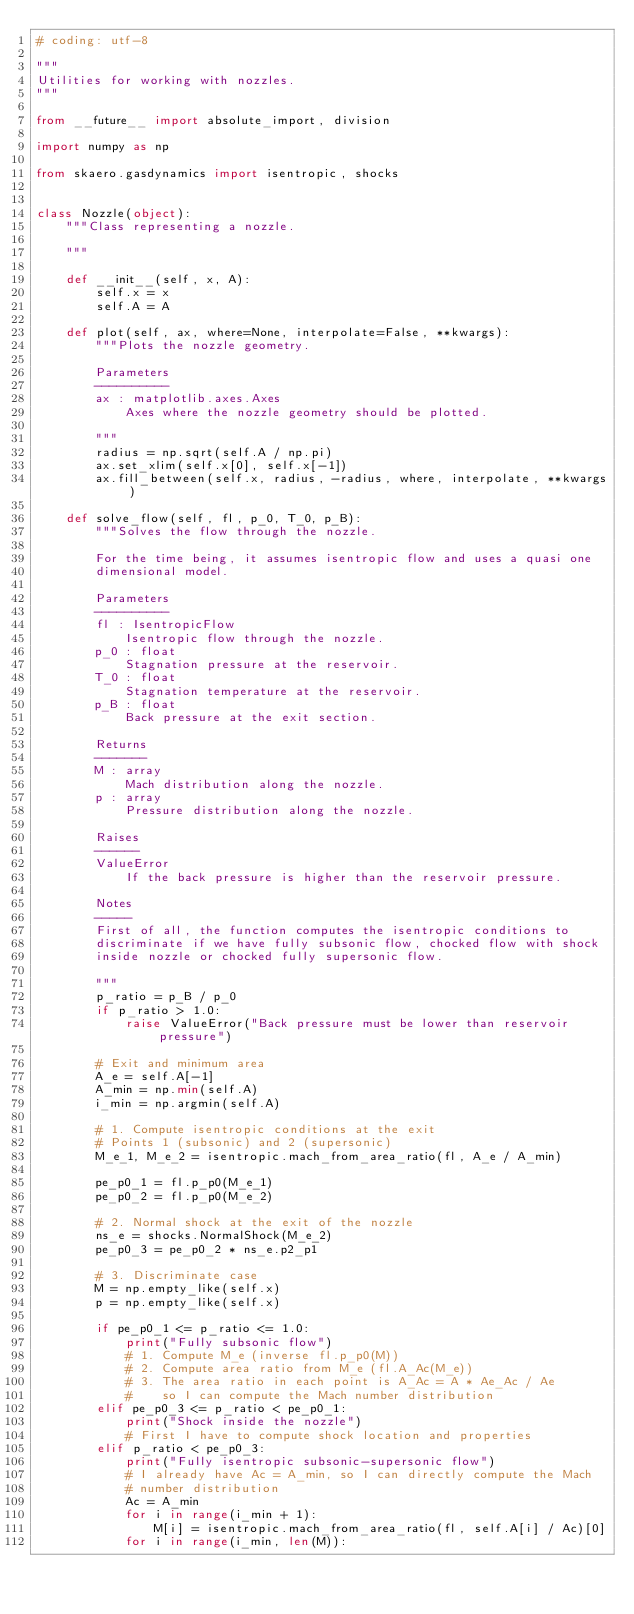<code> <loc_0><loc_0><loc_500><loc_500><_Python_># coding: utf-8

"""
Utilities for working with nozzles.
"""

from __future__ import absolute_import, division

import numpy as np

from skaero.gasdynamics import isentropic, shocks


class Nozzle(object):
    """Class representing a nozzle.

    """

    def __init__(self, x, A):
        self.x = x
        self.A = A

    def plot(self, ax, where=None, interpolate=False, **kwargs):
        """Plots the nozzle geometry.

        Parameters
        ----------
        ax : matplotlib.axes.Axes
            Axes where the nozzle geometry should be plotted.

        """
        radius = np.sqrt(self.A / np.pi)
        ax.set_xlim(self.x[0], self.x[-1])
        ax.fill_between(self.x, radius, -radius, where, interpolate, **kwargs)

    def solve_flow(self, fl, p_0, T_0, p_B):
        """Solves the flow through the nozzle.

        For the time being, it assumes isentropic flow and uses a quasi one
        dimensional model.

        Parameters
        ----------
        fl : IsentropicFlow
            Isentropic flow through the nozzle.
        p_0 : float
            Stagnation pressure at the reservoir.
        T_0 : float
            Stagnation temperature at the reservoir.
        p_B : float
            Back pressure at the exit section.

        Returns
        -------
        M : array
            Mach distribution along the nozzle.
        p : array
            Pressure distribution along the nozzle.

        Raises
        ------
        ValueError
            If the back pressure is higher than the reservoir pressure.

        Notes
        -----
        First of all, the function computes the isentropic conditions to
        discriminate if we have fully subsonic flow, chocked flow with shock
        inside nozzle or chocked fully supersonic flow.

        """
        p_ratio = p_B / p_0
        if p_ratio > 1.0:
            raise ValueError("Back pressure must be lower than reservoir pressure")

        # Exit and minimum area
        A_e = self.A[-1]
        A_min = np.min(self.A)
        i_min = np.argmin(self.A)

        # 1. Compute isentropic conditions at the exit
        # Points 1 (subsonic) and 2 (supersonic)
        M_e_1, M_e_2 = isentropic.mach_from_area_ratio(fl, A_e / A_min)

        pe_p0_1 = fl.p_p0(M_e_1)
        pe_p0_2 = fl.p_p0(M_e_2)

        # 2. Normal shock at the exit of the nozzle
        ns_e = shocks.NormalShock(M_e_2)
        pe_p0_3 = pe_p0_2 * ns_e.p2_p1

        # 3. Discriminate case
        M = np.empty_like(self.x)
        p = np.empty_like(self.x)

        if pe_p0_1 <= p_ratio <= 1.0:
            print("Fully subsonic flow")
            # 1. Compute M_e (inverse fl.p_p0(M))
            # 2. Compute area ratio from M_e (fl.A_Ac(M_e))
            # 3. The area ratio in each point is A_Ac = A * Ae_Ac / Ae
            #    so I can compute the Mach number distribution
        elif pe_p0_3 <= p_ratio < pe_p0_1:
            print("Shock inside the nozzle")
            # First I have to compute shock location and properties
        elif p_ratio < pe_p0_3:
            print("Fully isentropic subsonic-supersonic flow")
            # I already have Ac = A_min, so I can directly compute the Mach
            # number distribution
            Ac = A_min
            for i in range(i_min + 1):
                M[i] = isentropic.mach_from_area_ratio(fl, self.A[i] / Ac)[0]
            for i in range(i_min, len(M)):</code> 